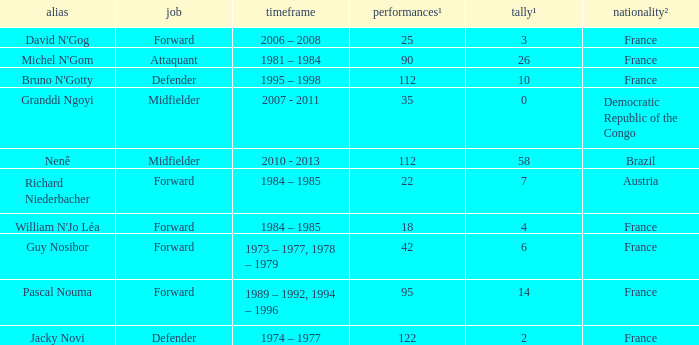List the number of active years for attaquant. 1981 – 1984. Parse the full table. {'header': ['alias', 'job', 'timeframe', 'performances¹', 'tally¹', 'nationality²'], 'rows': [["David N'Gog", 'Forward', '2006 – 2008', '25', '3', 'France'], ["Michel N'Gom", 'Attaquant', '1981 – 1984', '90', '26', 'France'], ["Bruno N'Gotty", 'Defender', '1995 – 1998', '112', '10', 'France'], ['Granddi Ngoyi', 'Midfielder', '2007 - 2011', '35', '0', 'Democratic Republic of the Congo'], ['Nenê', 'Midfielder', '2010 - 2013', '112', '58', 'Brazil'], ['Richard Niederbacher', 'Forward', '1984 – 1985', '22', '7', 'Austria'], ["William N'Jo Léa", 'Forward', '1984 – 1985', '18', '4', 'France'], ['Guy Nosibor', 'Forward', '1973 – 1977, 1978 – 1979', '42', '6', 'France'], ['Pascal Nouma', 'Forward', '1989 – 1992, 1994 – 1996', '95', '14', 'France'], ['Jacky Novi', 'Defender', '1974 – 1977', '122', '2', 'France']]} 